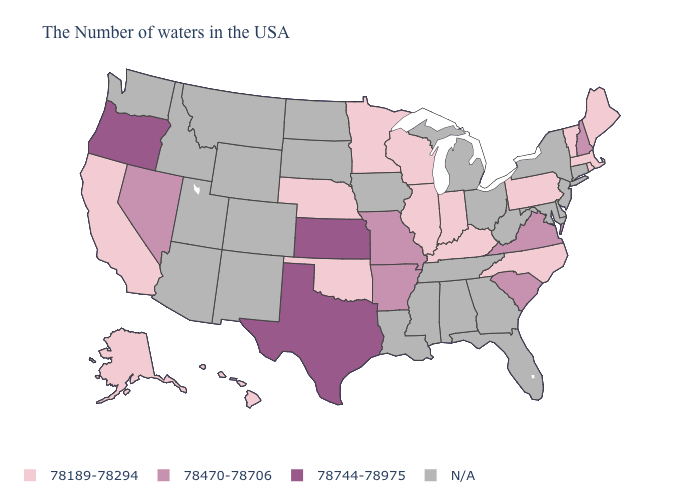Does New Hampshire have the lowest value in the USA?
Answer briefly. No. How many symbols are there in the legend?
Write a very short answer. 4. Name the states that have a value in the range 78470-78706?
Answer briefly. New Hampshire, Virginia, South Carolina, Missouri, Arkansas, Nevada. Name the states that have a value in the range 78470-78706?
Be succinct. New Hampshire, Virginia, South Carolina, Missouri, Arkansas, Nevada. Which states have the lowest value in the USA?
Answer briefly. Maine, Massachusetts, Rhode Island, Vermont, Pennsylvania, North Carolina, Kentucky, Indiana, Wisconsin, Illinois, Minnesota, Nebraska, Oklahoma, California, Alaska, Hawaii. What is the lowest value in the West?
Short answer required. 78189-78294. What is the value of Missouri?
Be succinct. 78470-78706. What is the highest value in the South ?
Give a very brief answer. 78744-78975. What is the highest value in the USA?
Short answer required. 78744-78975. What is the value of Michigan?
Concise answer only. N/A. Which states have the lowest value in the USA?
Quick response, please. Maine, Massachusetts, Rhode Island, Vermont, Pennsylvania, North Carolina, Kentucky, Indiana, Wisconsin, Illinois, Minnesota, Nebraska, Oklahoma, California, Alaska, Hawaii. Does the map have missing data?
Be succinct. Yes. Does Pennsylvania have the highest value in the USA?
Quick response, please. No. Which states hav the highest value in the Northeast?
Quick response, please. New Hampshire. What is the highest value in states that border Minnesota?
Quick response, please. 78189-78294. 